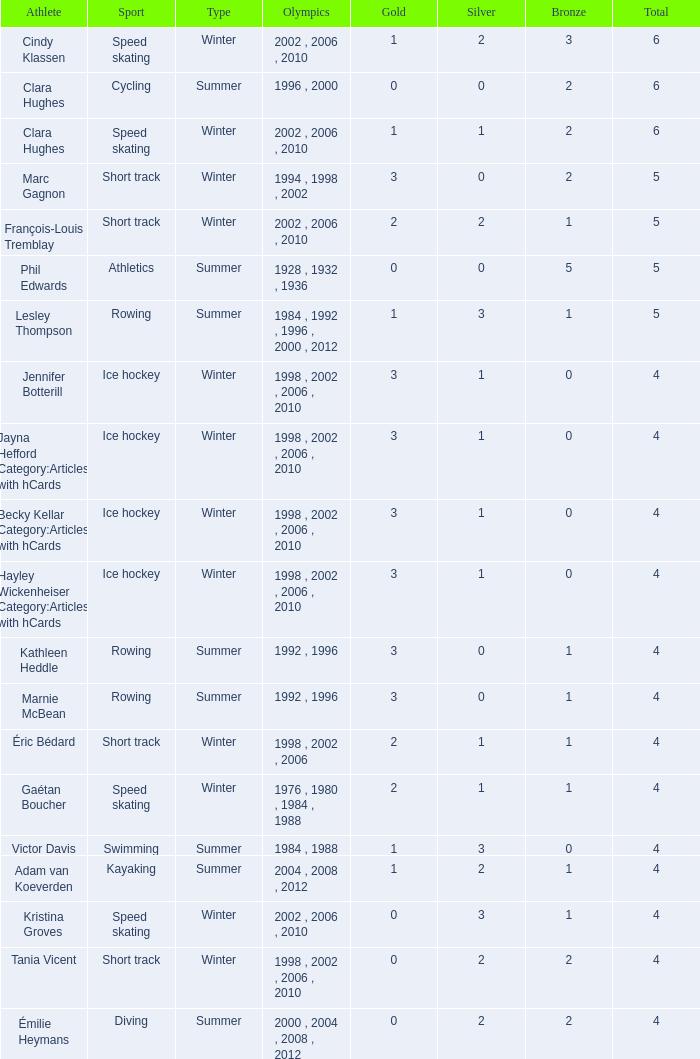What is the least number of bronze medals a short track athlete with no gold medals has? 2.0. 